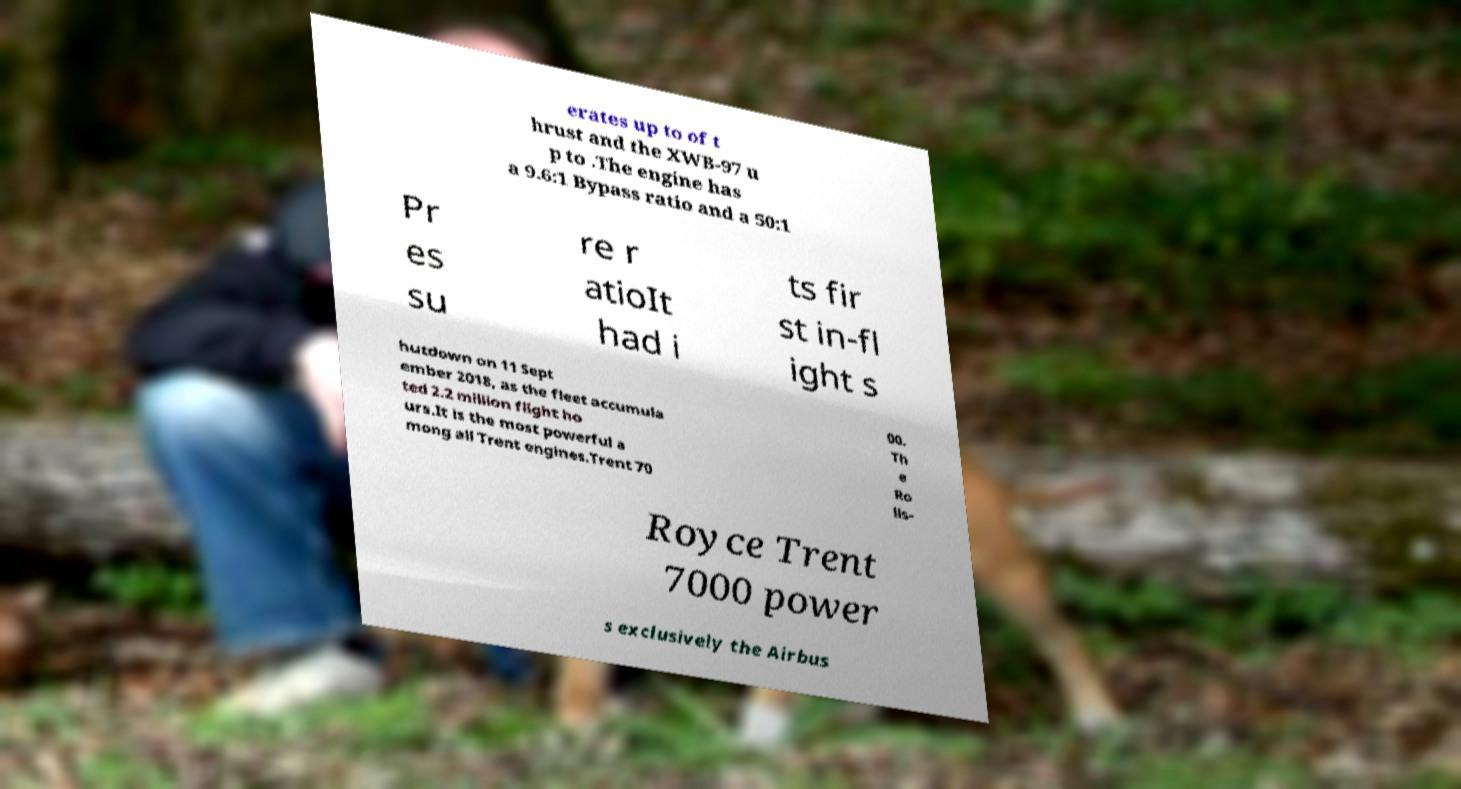Please identify and transcribe the text found in this image. erates up to of t hrust and the XWB-97 u p to .The engine has a 9.6:1 Bypass ratio and a 50:1 Pr es su re r atioIt had i ts fir st in-fl ight s hutdown on 11 Sept ember 2018, as the fleet accumula ted 2.2 million flight ho urs.It is the most powerful a mong all Trent engines.Trent 70 00. Th e Ro lls- Royce Trent 7000 power s exclusively the Airbus 